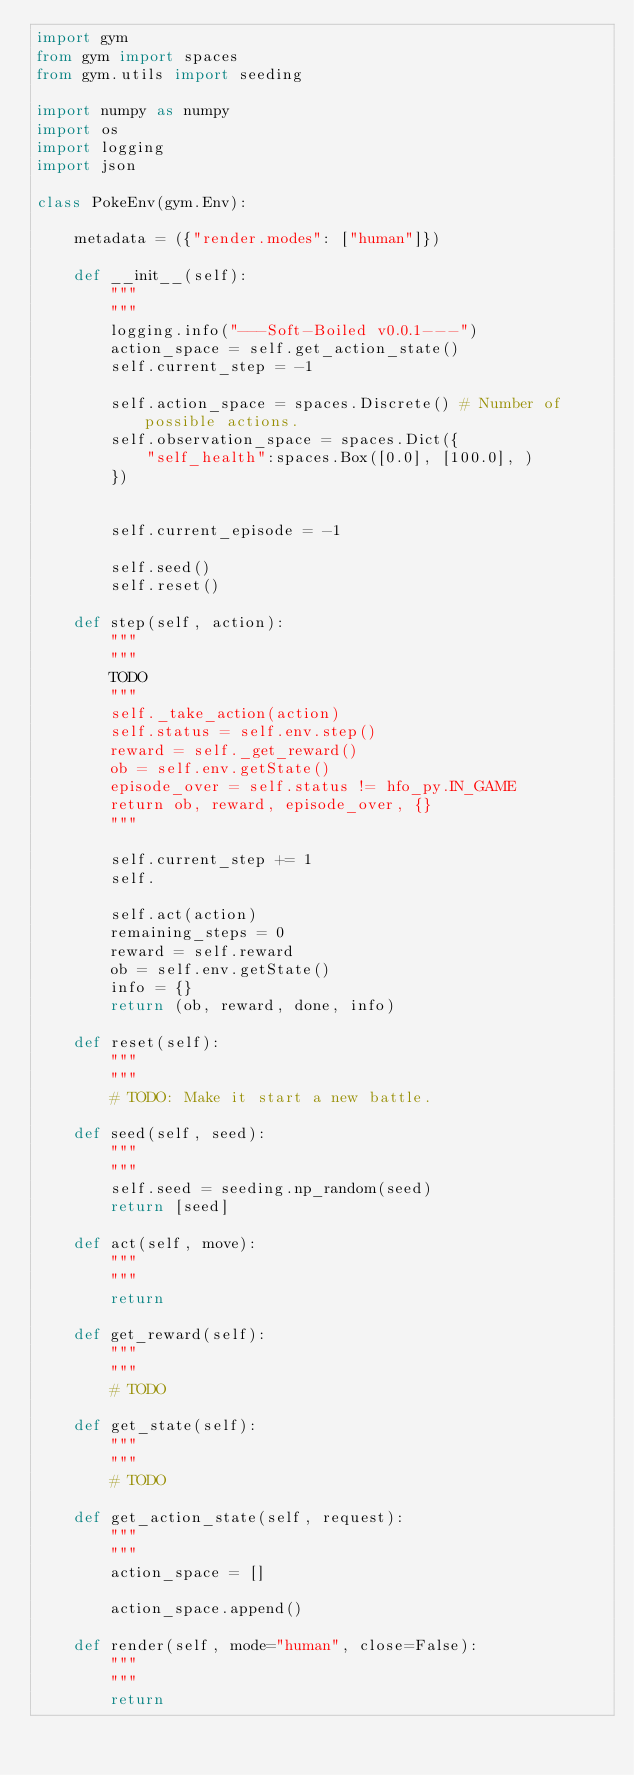<code> <loc_0><loc_0><loc_500><loc_500><_Python_>import gym
from gym import spaces
from gym.utils import seeding

import numpy as numpy
import os
import logging
import json

class PokeEnv(gym.Env):

    metadata = ({"render.modes": ["human"]})

    def __init__(self):
        """
        """
        logging.info("---Soft-Boiled v0.0.1---")
        action_space = self.get_action_state()
        self.current_step = -1

        self.action_space = spaces.Discrete() # Number of possible actions.
        self.observation_space = spaces.Dict({
            "self_health":spaces.Box([0.0], [100.0], )
        })


        self.current_episode = -1

        self.seed()
        self.reset()

    def step(self, action):
        """
        """
        TODO
        """
        self._take_action(action)
        self.status = self.env.step()
        reward = self._get_reward()
        ob = self.env.getState()
        episode_over = self.status != hfo_py.IN_GAME
        return ob, reward, episode_over, {}
        """

        self.current_step += 1
        self.

        self.act(action)
        remaining_steps = 0
        reward = self.reward
        ob = self.env.getState()
        info = {}
        return (ob, reward, done, info)
    
    def reset(self):
        """
        """
        # TODO: Make it start a new battle.

    def seed(self, seed):
        """
        """
        self.seed = seeding.np_random(seed)
        return [seed]

    def act(self, move):
        """
        """
        return
    
    def get_reward(self):
        """
        """
        # TODO
        
    def get_state(self):
        """
        """
        # TODO

    def get_action_state(self, request):
        """
        """
        action_space = []

        action_space.append()

    def render(self, mode="human", close=False):
        """
        """
        return

</code> 